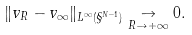<formula> <loc_0><loc_0><loc_500><loc_500>\| v _ { R } - v _ { \infty } \| _ { L ^ { \infty } ( \S ^ { N - 1 } ) } \underset { R \to + \infty } { \to } 0 .</formula> 